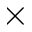<formula> <loc_0><loc_0><loc_500><loc_500>\times</formula> 